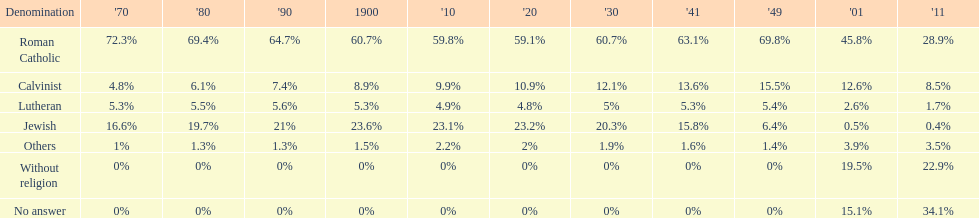What is the total percentage of people who identified as religious in 2011? 43%. Help me parse the entirety of this table. {'header': ['Denomination', "'70", "'80", "'90", '1900', "'10", "'20", "'30", "'41", "'49", "'01", "'11"], 'rows': [['Roman Catholic', '72.3%', '69.4%', '64.7%', '60.7%', '59.8%', '59.1%', '60.7%', '63.1%', '69.8%', '45.8%', '28.9%'], ['Calvinist', '4.8%', '6.1%', '7.4%', '8.9%', '9.9%', '10.9%', '12.1%', '13.6%', '15.5%', '12.6%', '8.5%'], ['Lutheran', '5.3%', '5.5%', '5.6%', '5.3%', '4.9%', '4.8%', '5%', '5.3%', '5.4%', '2.6%', '1.7%'], ['Jewish', '16.6%', '19.7%', '21%', '23.6%', '23.1%', '23.2%', '20.3%', '15.8%', '6.4%', '0.5%', '0.4%'], ['Others', '1%', '1.3%', '1.3%', '1.5%', '2.2%', '2%', '1.9%', '1.6%', '1.4%', '3.9%', '3.5%'], ['Without religion', '0%', '0%', '0%', '0%', '0%', '0%', '0%', '0%', '0%', '19.5%', '22.9%'], ['No answer', '0%', '0%', '0%', '0%', '0%', '0%', '0%', '0%', '0%', '15.1%', '34.1%']]} 